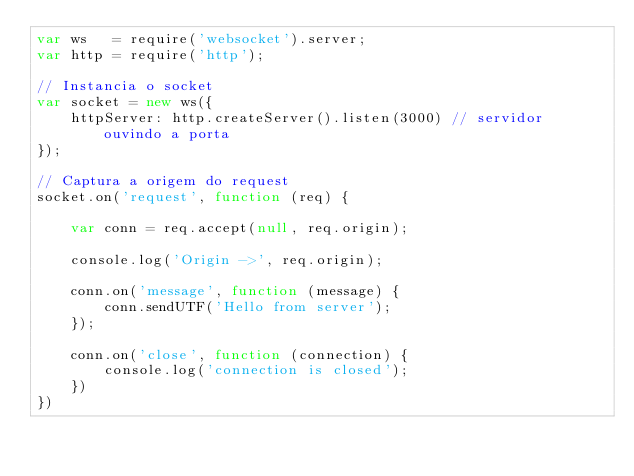Convert code to text. <code><loc_0><loc_0><loc_500><loc_500><_JavaScript_>var ws   = require('websocket').server;
var http = require('http');

// Instancia o socket
var socket = new ws({
    httpServer: http.createServer().listen(3000) // servidor ouvindo a porta
});

// Captura a origem do request
socket.on('request', function (req) {

    var conn = req.accept(null, req.origin);

    console.log('Origin ->', req.origin);

    conn.on('message', function (message) {
        conn.sendUTF('Hello from server');
    });

    conn.on('close', function (connection) {
        console.log('connection is closed');
    })
})</code> 